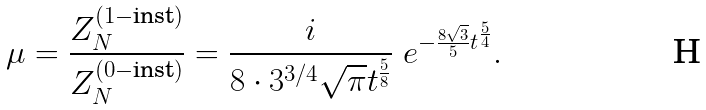<formula> <loc_0><loc_0><loc_500><loc_500>\mu = \frac { Z _ { N } ^ { ( 1 - \text {inst} ) } } { Z _ { N } ^ { ( 0 - \text {inst} ) } } = \frac { i } { 8 \cdot 3 ^ { 3 / 4 } \sqrt { \pi } t ^ { \frac { 5 } { 8 } } } \ e ^ { - \frac { 8 \sqrt { 3 } } { 5 } t ^ { \frac { 5 } { 4 } } } .</formula> 